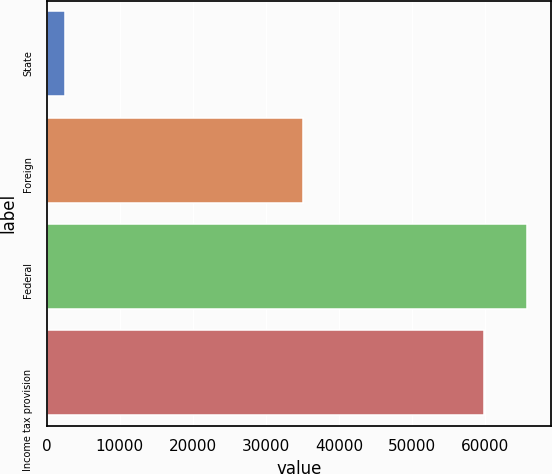Convert chart. <chart><loc_0><loc_0><loc_500><loc_500><bar_chart><fcel>State<fcel>Foreign<fcel>Federal<fcel>Income tax provision<nl><fcel>2531<fcel>35127<fcel>65707.2<fcel>59809<nl></chart> 